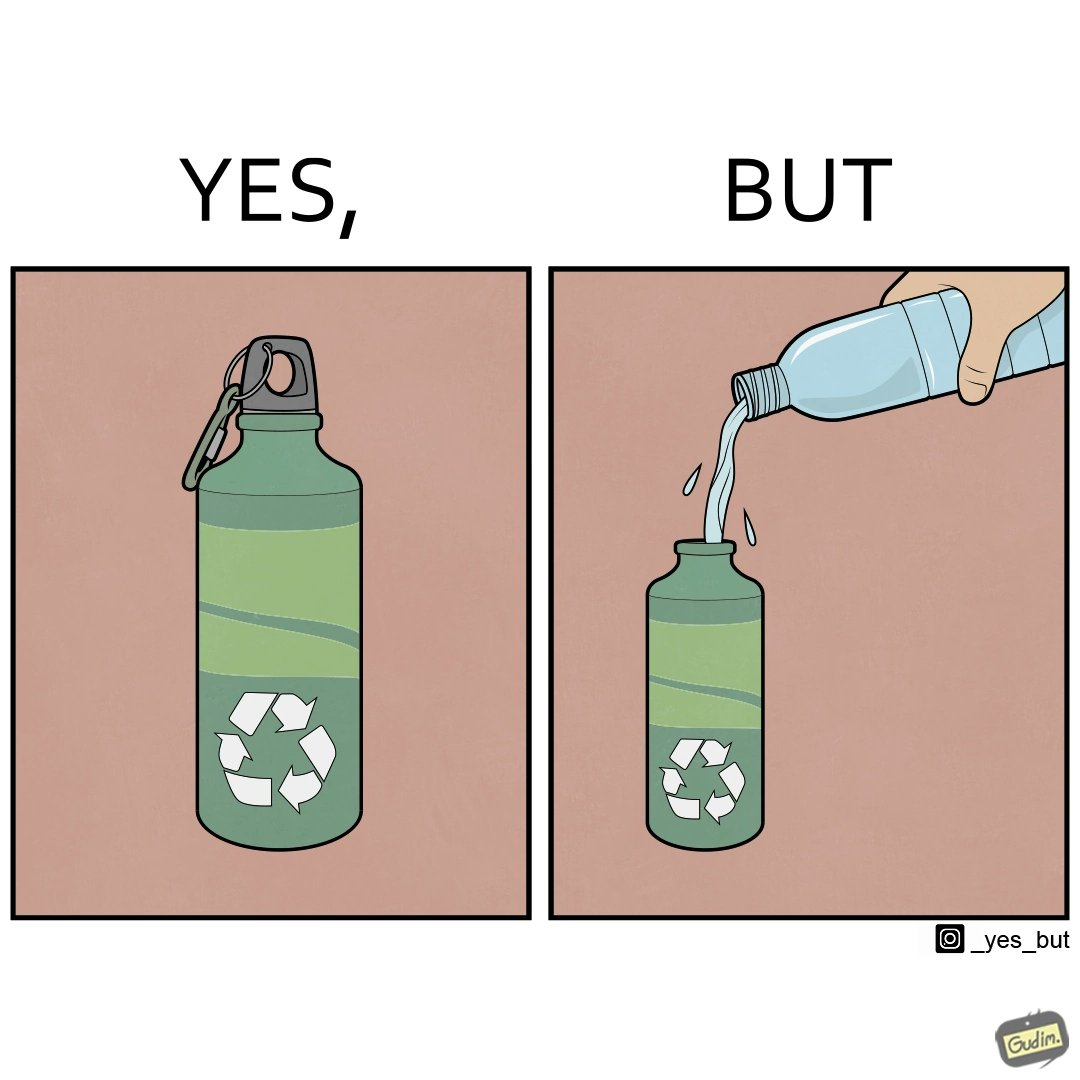Is this a satirical image? Yes, this image is satirical. 